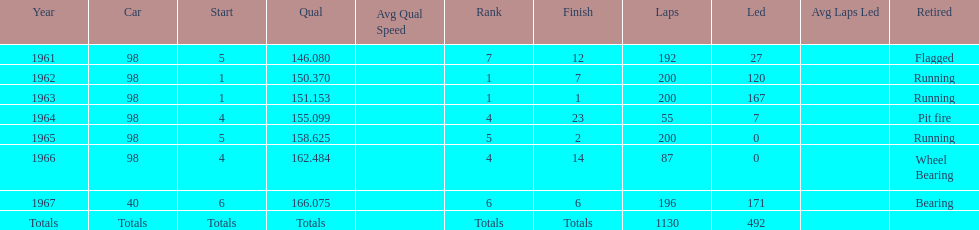In how many indy 500 races, has jones been flagged? 1. 